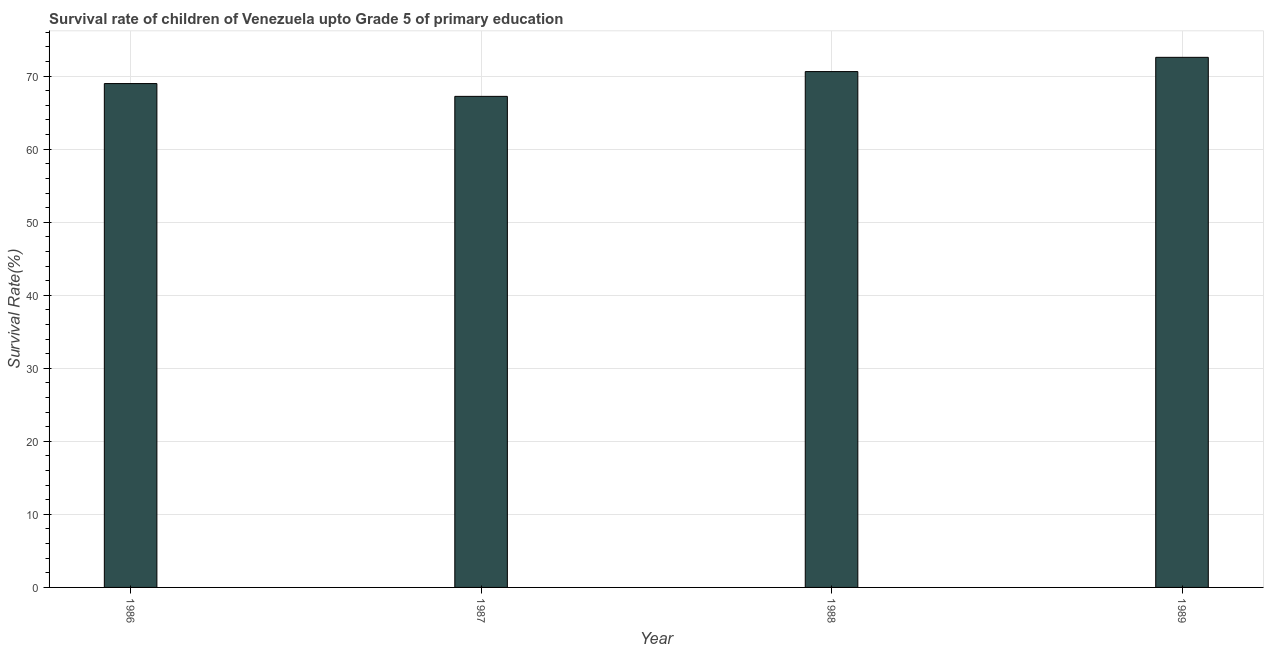Does the graph contain any zero values?
Provide a succinct answer. No. What is the title of the graph?
Your answer should be very brief. Survival rate of children of Venezuela upto Grade 5 of primary education. What is the label or title of the Y-axis?
Keep it short and to the point. Survival Rate(%). What is the survival rate in 1989?
Your answer should be compact. 72.58. Across all years, what is the maximum survival rate?
Offer a terse response. 72.58. Across all years, what is the minimum survival rate?
Your response must be concise. 67.23. In which year was the survival rate maximum?
Your response must be concise. 1989. What is the sum of the survival rate?
Offer a terse response. 279.42. What is the difference between the survival rate in 1986 and 1989?
Make the answer very short. -3.59. What is the average survival rate per year?
Offer a very short reply. 69.85. What is the median survival rate?
Make the answer very short. 69.8. Do a majority of the years between 1986 and 1989 (inclusive) have survival rate greater than 52 %?
Offer a terse response. Yes. Is the survival rate in 1986 less than that in 1987?
Give a very brief answer. No. Is the difference between the survival rate in 1986 and 1987 greater than the difference between any two years?
Make the answer very short. No. What is the difference between the highest and the second highest survival rate?
Your answer should be very brief. 1.95. Is the sum of the survival rate in 1986 and 1987 greater than the maximum survival rate across all years?
Give a very brief answer. Yes. What is the difference between the highest and the lowest survival rate?
Your response must be concise. 5.34. Are the values on the major ticks of Y-axis written in scientific E-notation?
Provide a succinct answer. No. What is the Survival Rate(%) in 1986?
Offer a very short reply. 68.98. What is the Survival Rate(%) of 1987?
Give a very brief answer. 67.23. What is the Survival Rate(%) of 1988?
Offer a terse response. 70.62. What is the Survival Rate(%) of 1989?
Make the answer very short. 72.58. What is the difference between the Survival Rate(%) in 1986 and 1987?
Provide a short and direct response. 1.75. What is the difference between the Survival Rate(%) in 1986 and 1988?
Your answer should be compact. -1.64. What is the difference between the Survival Rate(%) in 1986 and 1989?
Give a very brief answer. -3.59. What is the difference between the Survival Rate(%) in 1987 and 1988?
Your answer should be compact. -3.39. What is the difference between the Survival Rate(%) in 1987 and 1989?
Offer a terse response. -5.34. What is the difference between the Survival Rate(%) in 1988 and 1989?
Keep it short and to the point. -1.95. What is the ratio of the Survival Rate(%) in 1986 to that in 1987?
Your answer should be very brief. 1.03. What is the ratio of the Survival Rate(%) in 1986 to that in 1989?
Keep it short and to the point. 0.95. What is the ratio of the Survival Rate(%) in 1987 to that in 1988?
Offer a terse response. 0.95. What is the ratio of the Survival Rate(%) in 1987 to that in 1989?
Offer a very short reply. 0.93. 